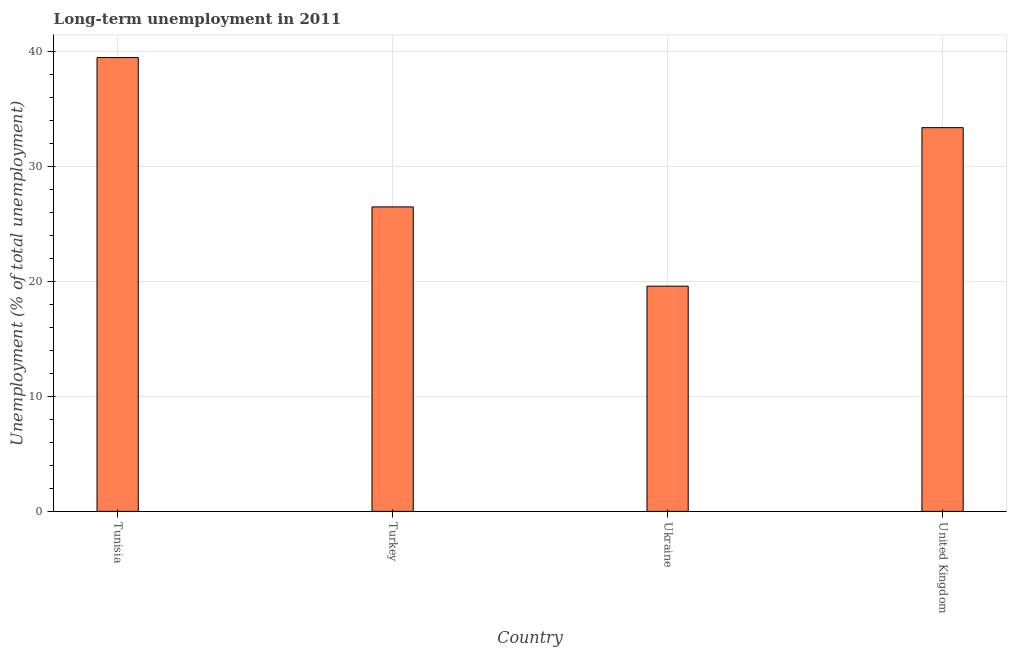What is the title of the graph?
Your answer should be compact. Long-term unemployment in 2011. What is the label or title of the Y-axis?
Keep it short and to the point. Unemployment (% of total unemployment). What is the long-term unemployment in United Kingdom?
Make the answer very short. 33.4. Across all countries, what is the maximum long-term unemployment?
Provide a succinct answer. 39.5. Across all countries, what is the minimum long-term unemployment?
Provide a succinct answer. 19.6. In which country was the long-term unemployment maximum?
Ensure brevity in your answer.  Tunisia. In which country was the long-term unemployment minimum?
Make the answer very short. Ukraine. What is the sum of the long-term unemployment?
Provide a succinct answer. 119. What is the difference between the long-term unemployment in Tunisia and Ukraine?
Keep it short and to the point. 19.9. What is the average long-term unemployment per country?
Your answer should be compact. 29.75. What is the median long-term unemployment?
Keep it short and to the point. 29.95. What is the ratio of the long-term unemployment in Turkey to that in Ukraine?
Provide a succinct answer. 1.35. Is the long-term unemployment in Turkey less than that in United Kingdom?
Give a very brief answer. Yes. Is the difference between the long-term unemployment in Turkey and Ukraine greater than the difference between any two countries?
Your answer should be very brief. No. What is the difference between the highest and the second highest long-term unemployment?
Offer a terse response. 6.1. What is the difference between the highest and the lowest long-term unemployment?
Offer a very short reply. 19.9. How many bars are there?
Offer a very short reply. 4. Are all the bars in the graph horizontal?
Keep it short and to the point. No. What is the Unemployment (% of total unemployment) in Tunisia?
Give a very brief answer. 39.5. What is the Unemployment (% of total unemployment) in Turkey?
Keep it short and to the point. 26.5. What is the Unemployment (% of total unemployment) of Ukraine?
Provide a short and direct response. 19.6. What is the Unemployment (% of total unemployment) of United Kingdom?
Provide a short and direct response. 33.4. What is the difference between the Unemployment (% of total unemployment) in Tunisia and Turkey?
Offer a terse response. 13. What is the difference between the Unemployment (% of total unemployment) in Tunisia and United Kingdom?
Give a very brief answer. 6.1. What is the difference between the Unemployment (% of total unemployment) in Turkey and Ukraine?
Make the answer very short. 6.9. What is the difference between the Unemployment (% of total unemployment) in Turkey and United Kingdom?
Your response must be concise. -6.9. What is the ratio of the Unemployment (% of total unemployment) in Tunisia to that in Turkey?
Offer a very short reply. 1.49. What is the ratio of the Unemployment (% of total unemployment) in Tunisia to that in Ukraine?
Provide a short and direct response. 2.02. What is the ratio of the Unemployment (% of total unemployment) in Tunisia to that in United Kingdom?
Ensure brevity in your answer.  1.18. What is the ratio of the Unemployment (% of total unemployment) in Turkey to that in Ukraine?
Your response must be concise. 1.35. What is the ratio of the Unemployment (% of total unemployment) in Turkey to that in United Kingdom?
Ensure brevity in your answer.  0.79. What is the ratio of the Unemployment (% of total unemployment) in Ukraine to that in United Kingdom?
Your answer should be very brief. 0.59. 